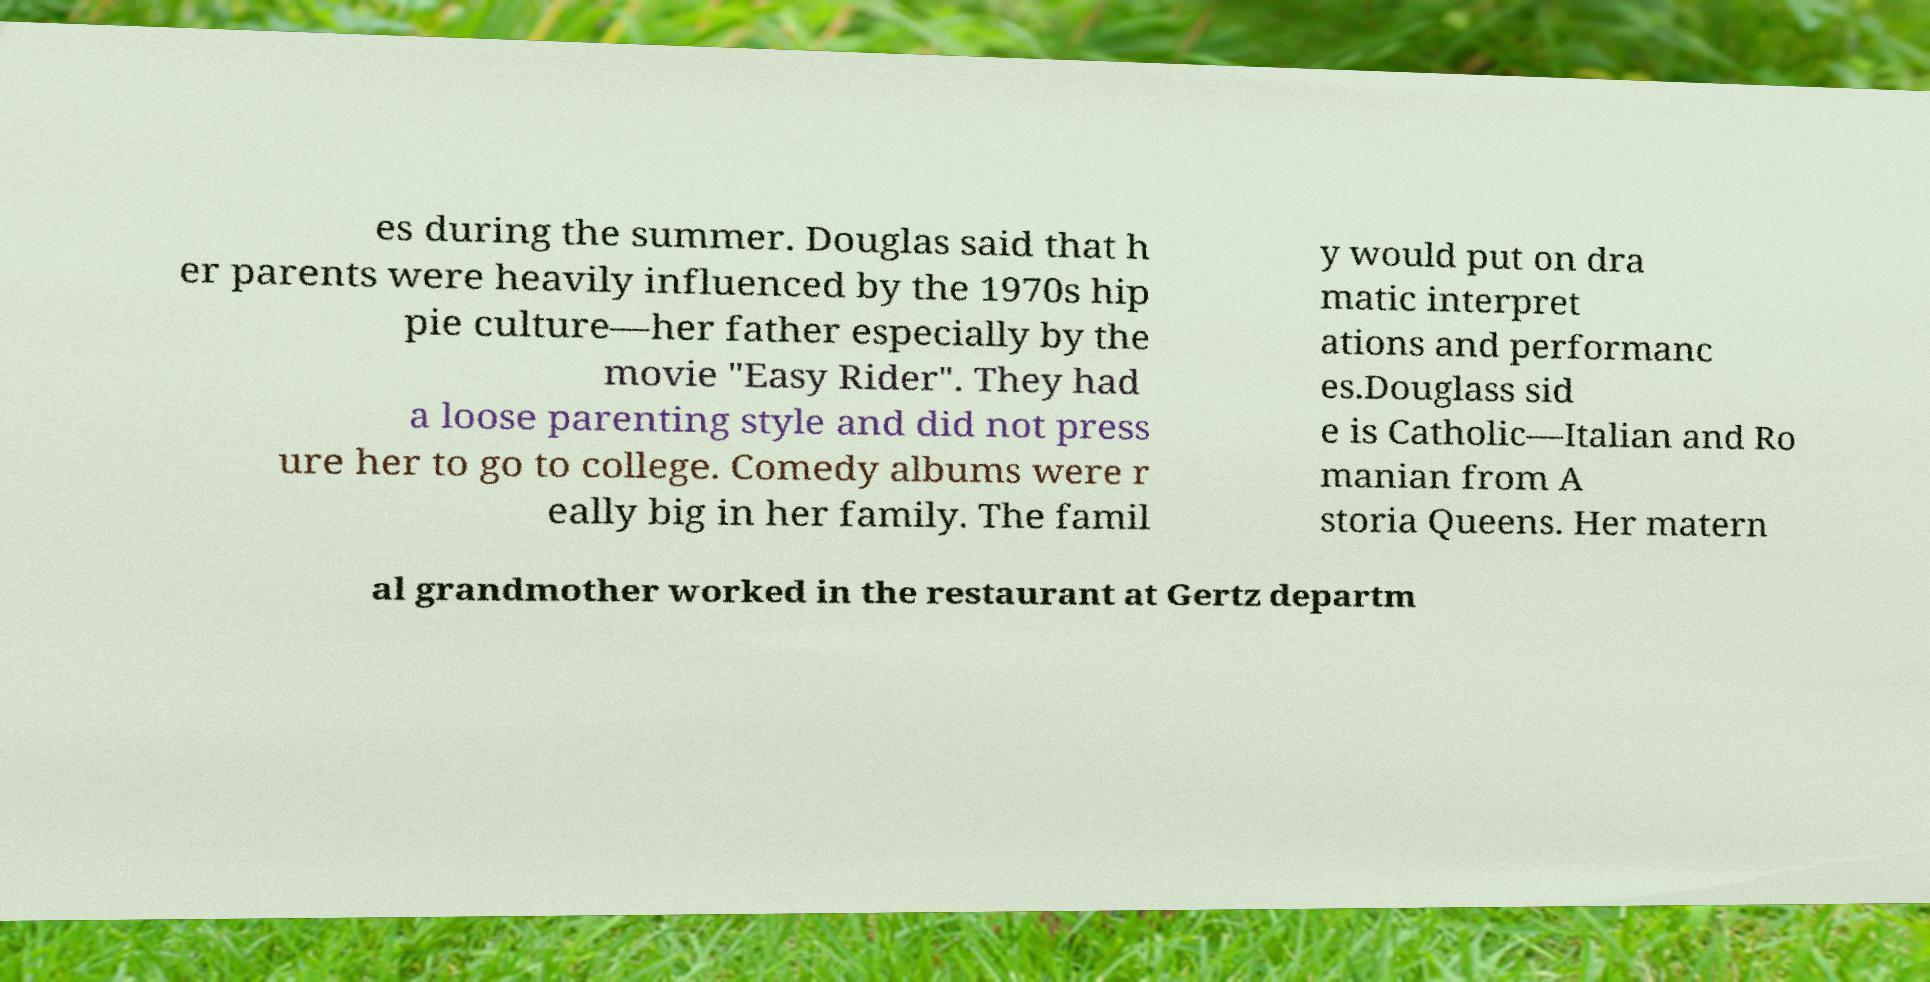For documentation purposes, I need the text within this image transcribed. Could you provide that? es during the summer. Douglas said that h er parents were heavily influenced by the 1970s hip pie culture—her father especially by the movie "Easy Rider". They had a loose parenting style and did not press ure her to go to college. Comedy albums were r eally big in her family. The famil y would put on dra matic interpret ations and performanc es.Douglass sid e is Catholic—Italian and Ro manian from A storia Queens. Her matern al grandmother worked in the restaurant at Gertz departm 